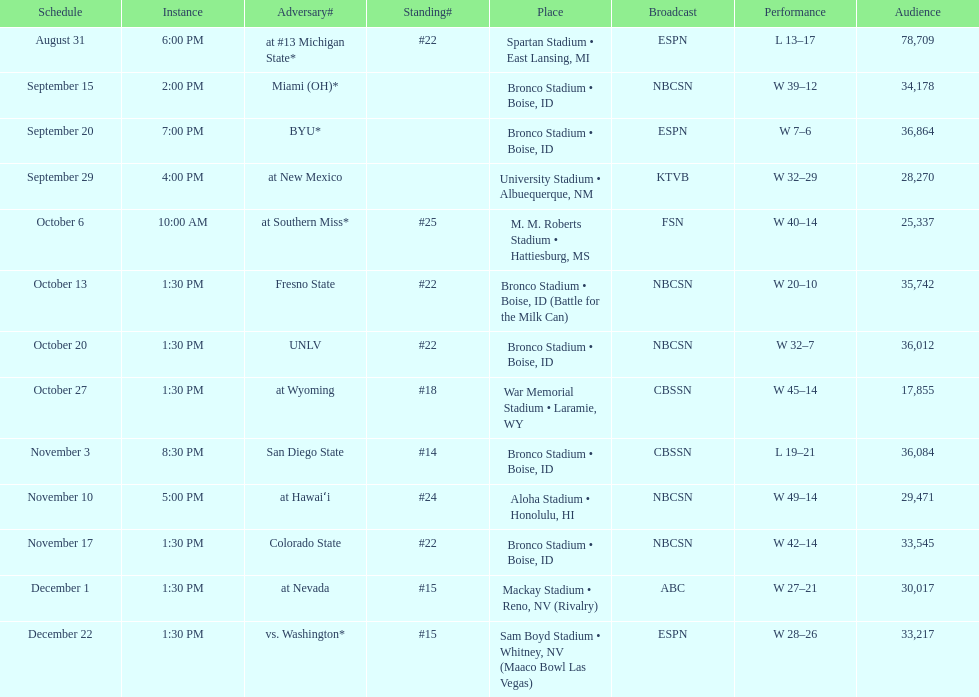What was there top ranked position of the season? #14. 